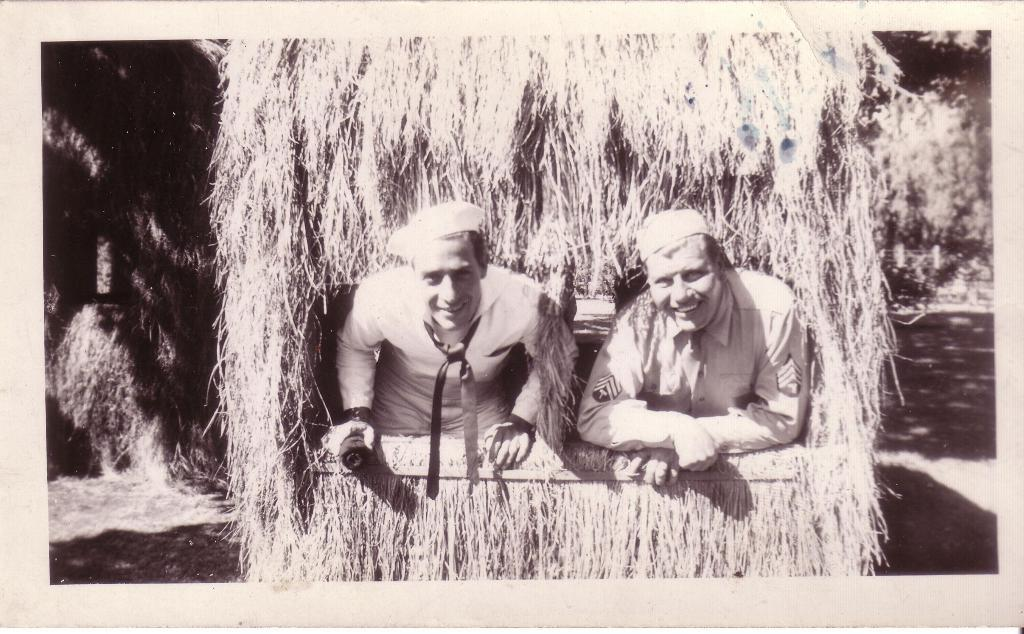What is the main subject in the image? There is a vehicle in the image. What type of environment is depicted in the image? Dry grass is present in the image. How many people are in the image? There are two people in the image. What are the people wearing? The two people are wearing white color shirts. Where is the scarecrow located in the image? There is no scarecrow present in the image. What is the range of the vehicle in the image? The range of the vehicle cannot be determined from the image alone. 